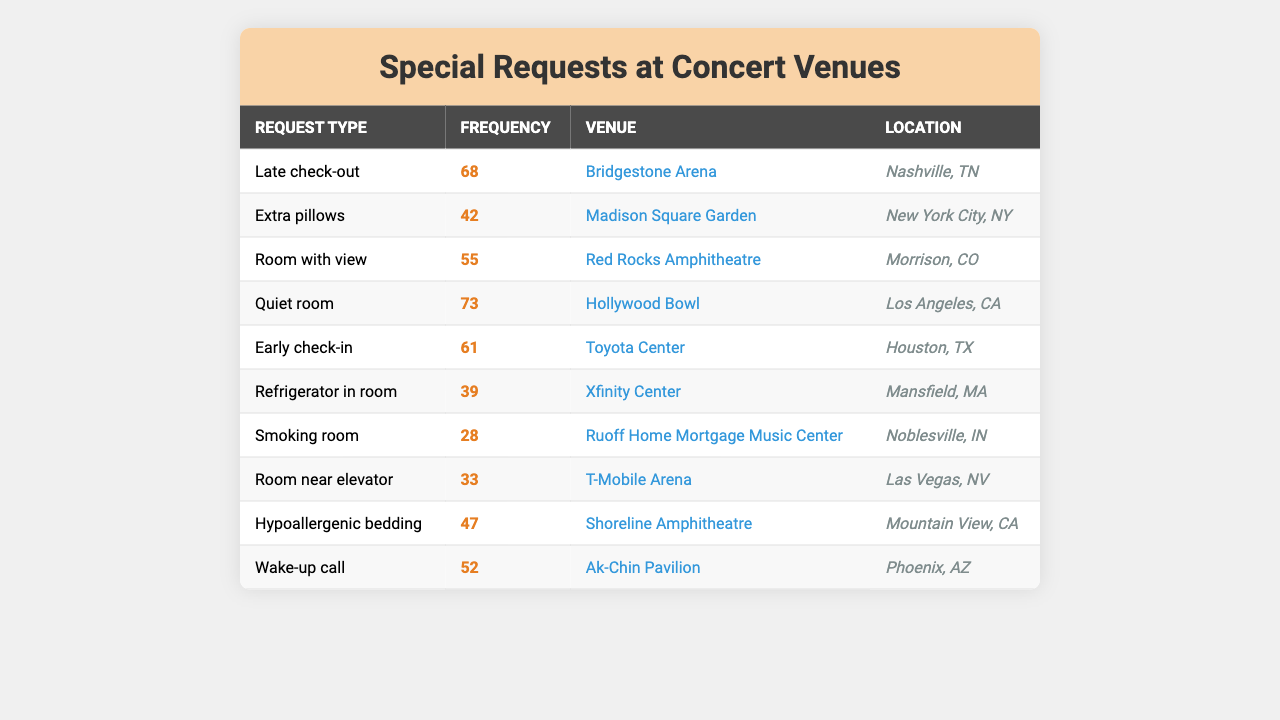What is the most common special request made by traveling salesmen? The most common special request is late check-out with a frequency of 68.
Answer: Late check-out Which venue has the least number of special requests? The special request with the least frequency is for a smoking room at 28.
Answer: Smoking room How many total requests for extra pillows and hypoallergenic bedding were made? The frequencies for extra pillows and hypoallergenic bedding are 42 and 47 respectively. Adding these gives 42 + 47 = 89.
Answer: 89 Is there a special request for early check-in at any venue? Yes, there is a request for early check-in at the Toyota Center in Houston, TX with a frequency of 61.
Answer: Yes What is the median frequency of special requests listed in the table? The frequencies of special requests are sorted as follows: 28, 33, 39, 42, 47, 52, 55, 61, 68, 73. There are 10 data points, so the median is the average of the 5th and 6th values: (47 + 52) / 2 = 49.5.
Answer: 49.5 Which city has the highest frequency of special requests and what is the request type? The city with the highest frequency of special requests is Los Angeles with a request for a quiet room at 73.
Answer: Los Angeles, Quiet room What percentage of total requests are for late check-out? The total frequency of special requests is 468. Late check-out frequency is 68, so (68/468) * 100 = 14.53%.
Answer: 14.53% How many more requests are for quiet rooms than for smoking rooms? The frequency for quiet rooms is 73 and for smoking rooms is 28. The difference is 73 - 28 = 45.
Answer: 45 Do more salesmen request refrigerators in their rooms or wake-up calls? Frequencies show 39 requests for refrigerators and 52 for wake-up calls. Since 52 > 39, more requests are for wake-up calls.
Answer: Wake-up calls Which venue has the highest request for a room with a view? The highest request for a room with a view is at Red Rocks Amphitheatre with a frequency of 55.
Answer: Red Rocks Amphitheatre 